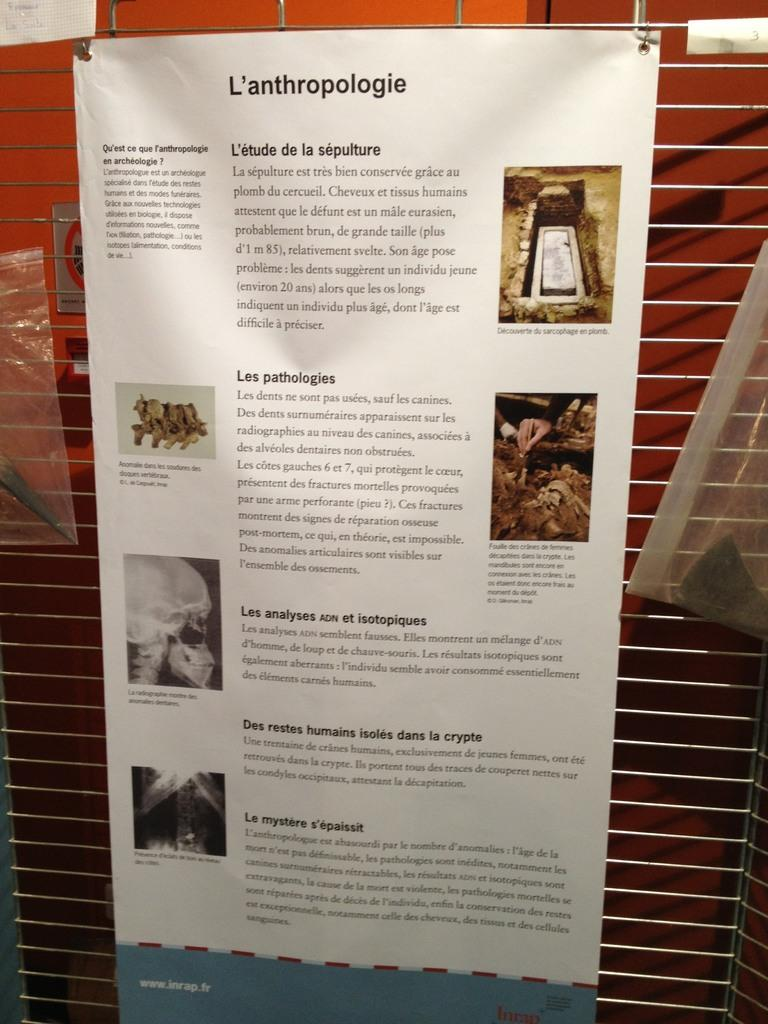<image>
Describe the image concisely. An informative fact sheet that says "L'anthropologie" is hung up for display. 